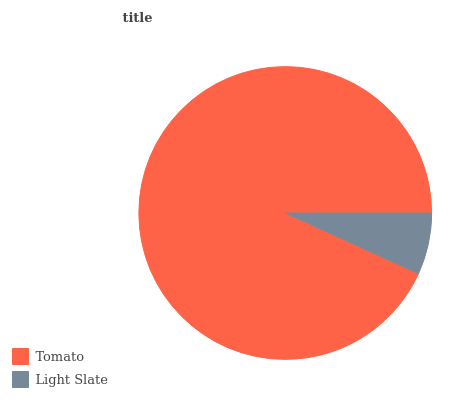Is Light Slate the minimum?
Answer yes or no. Yes. Is Tomato the maximum?
Answer yes or no. Yes. Is Light Slate the maximum?
Answer yes or no. No. Is Tomato greater than Light Slate?
Answer yes or no. Yes. Is Light Slate less than Tomato?
Answer yes or no. Yes. Is Light Slate greater than Tomato?
Answer yes or no. No. Is Tomato less than Light Slate?
Answer yes or no. No. Is Tomato the high median?
Answer yes or no. Yes. Is Light Slate the low median?
Answer yes or no. Yes. Is Light Slate the high median?
Answer yes or no. No. Is Tomato the low median?
Answer yes or no. No. 